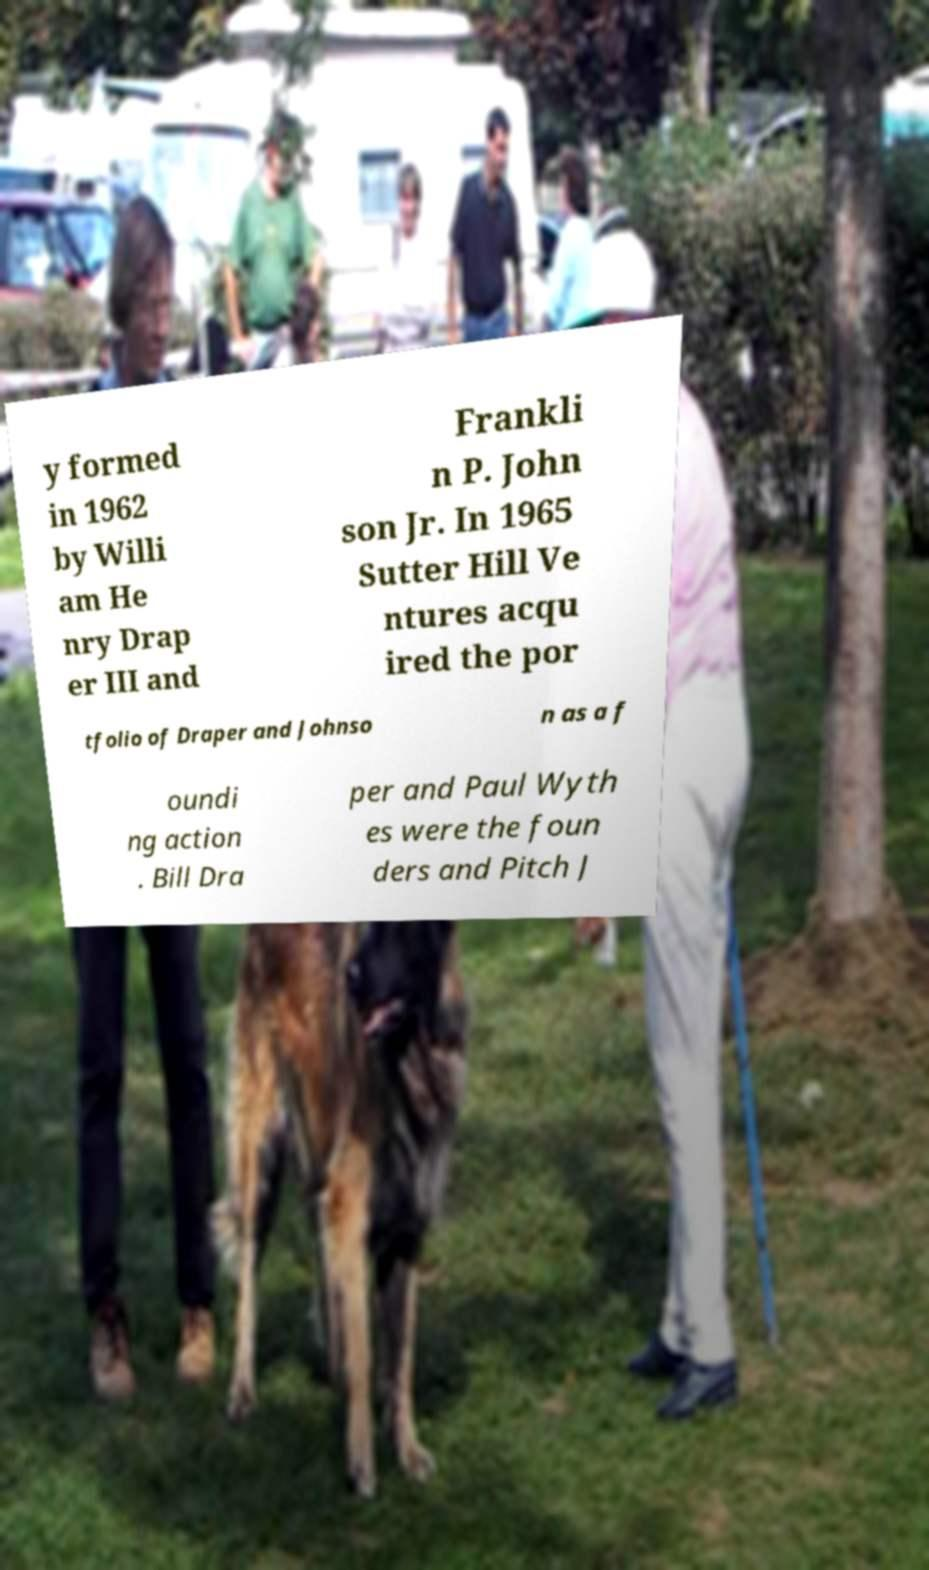Can you accurately transcribe the text from the provided image for me? y formed in 1962 by Willi am He nry Drap er III and Frankli n P. John son Jr. In 1965 Sutter Hill Ve ntures acqu ired the por tfolio of Draper and Johnso n as a f oundi ng action . Bill Dra per and Paul Wyth es were the foun ders and Pitch J 